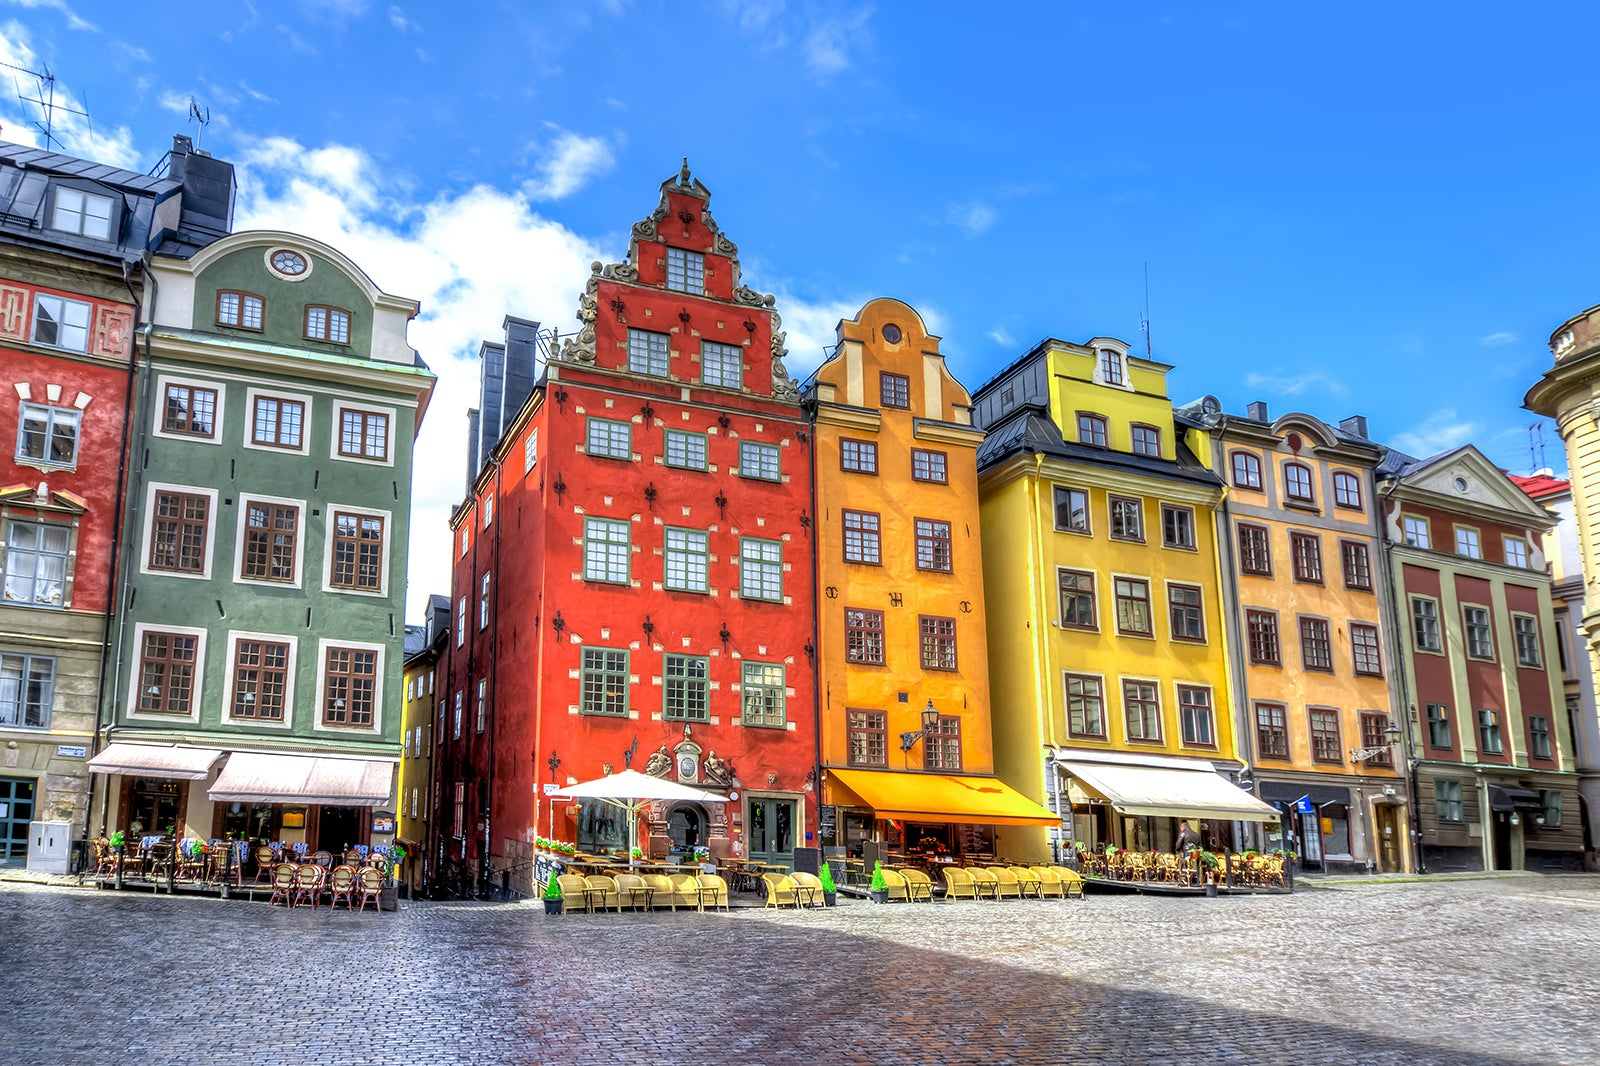Can you describe the types of businesses and activities commonly found on this street? This picturesque street in Gamla Stan is lined with a variety of businesses, predominantly cafes, restaurants, and souvenir shops catering to the area's heavy foot traffic from both locals and tourists. The eateries offer outdoor seating, perfect for enjoying the scenic views and vibrant atmosphere of the old town while partaking in Swedish or international cuisine. The shops often sell artisan crafts, local arts, and historical mementos, making this area not just a culinary delight but also a shopping destination for those looking to take a piece of Swedish culture home. 